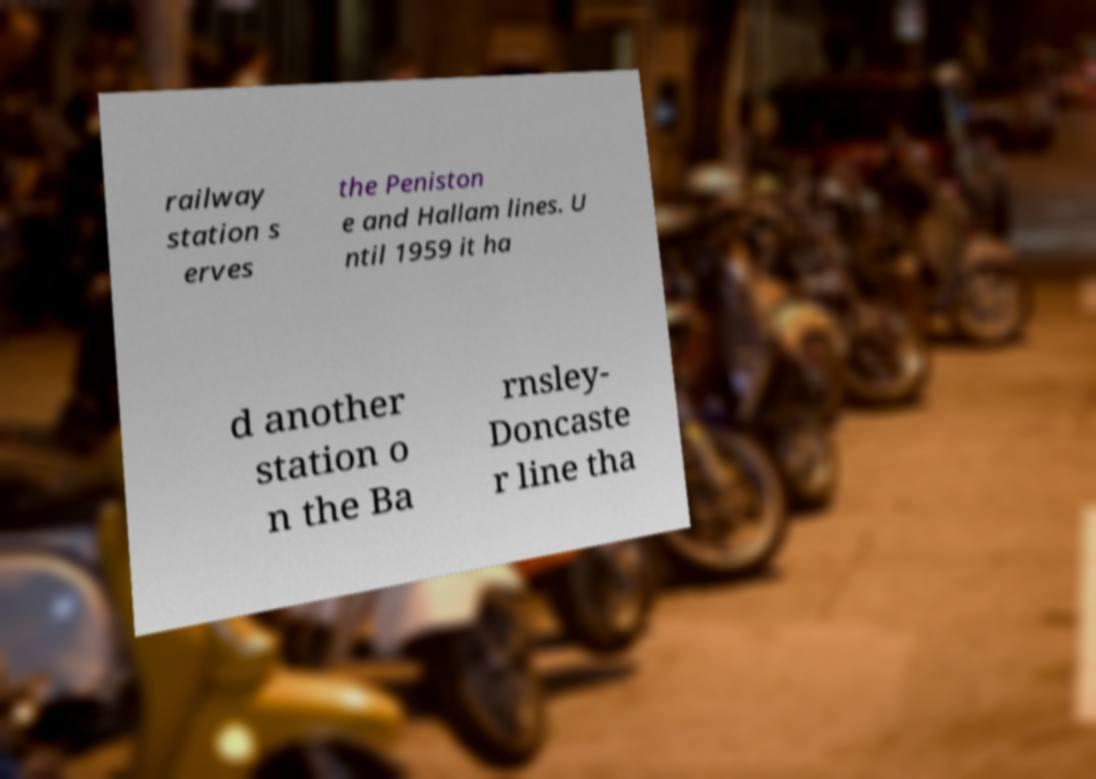Can you read and provide the text displayed in the image?This photo seems to have some interesting text. Can you extract and type it out for me? railway station s erves the Peniston e and Hallam lines. U ntil 1959 it ha d another station o n the Ba rnsley- Doncaste r line tha 